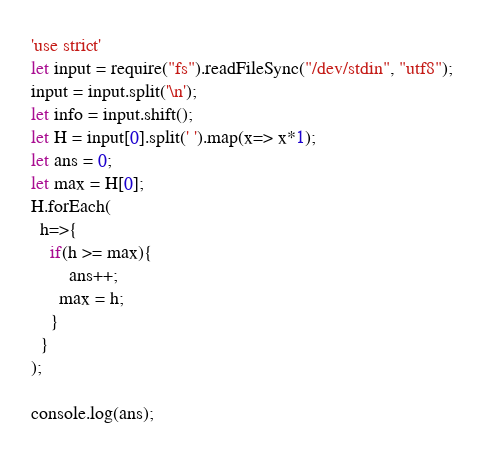Convert code to text. <code><loc_0><loc_0><loc_500><loc_500><_JavaScript_>'use strict'
let input = require("fs").readFileSync("/dev/stdin", "utf8");
input = input.split('\n');
let info = input.shift();
let H = input[0].split(' ').map(x=> x*1);
let ans = 0;
let max = H[0];
H.forEach(
  h=>{
    if(h >= max){
    	ans++;
      max = h;
    }
  }
);

console.log(ans);</code> 